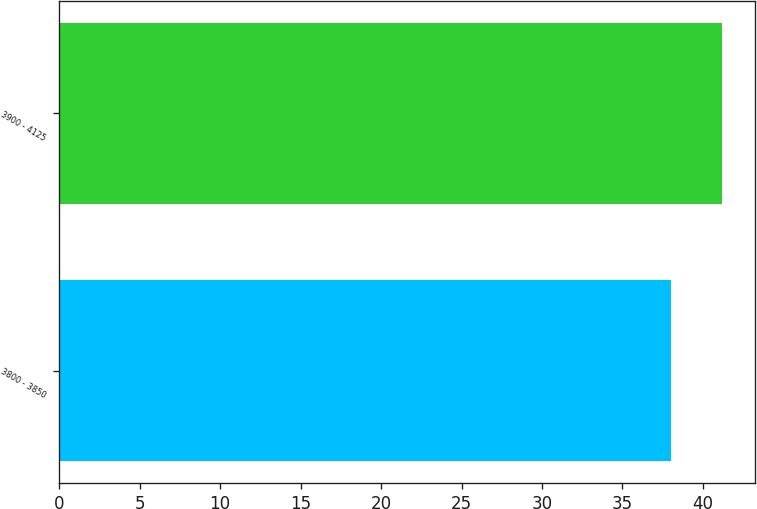<chart> <loc_0><loc_0><loc_500><loc_500><bar_chart><fcel>3800 - 3850<fcel>3900 - 4125<nl><fcel>38<fcel>41.2<nl></chart> 